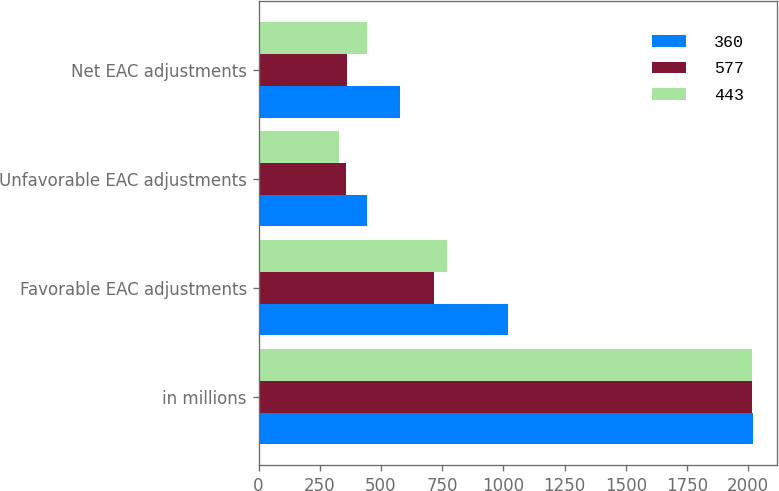Convert chart. <chart><loc_0><loc_0><loc_500><loc_500><stacked_bar_chart><ecel><fcel>in millions<fcel>Favorable EAC adjustments<fcel>Unfavorable EAC adjustments<fcel>Net EAC adjustments<nl><fcel>360<fcel>2018<fcel>1019<fcel>442<fcel>577<nl><fcel>577<fcel>2017<fcel>717<fcel>357<fcel>360<nl><fcel>443<fcel>2016<fcel>771<fcel>328<fcel>443<nl></chart> 